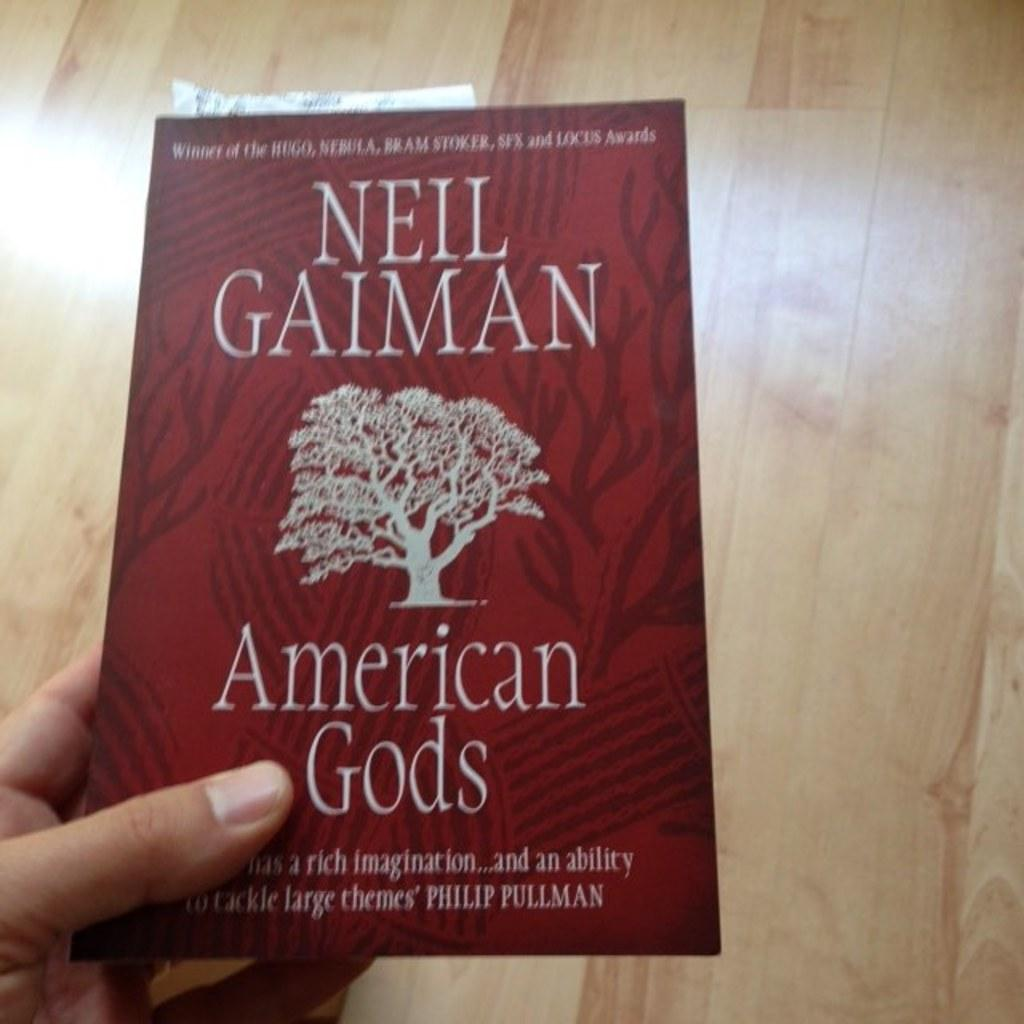<image>
Create a compact narrative representing the image presented. A hand holds a red book called American Gods by Neil Gaiman above a wooden floor 